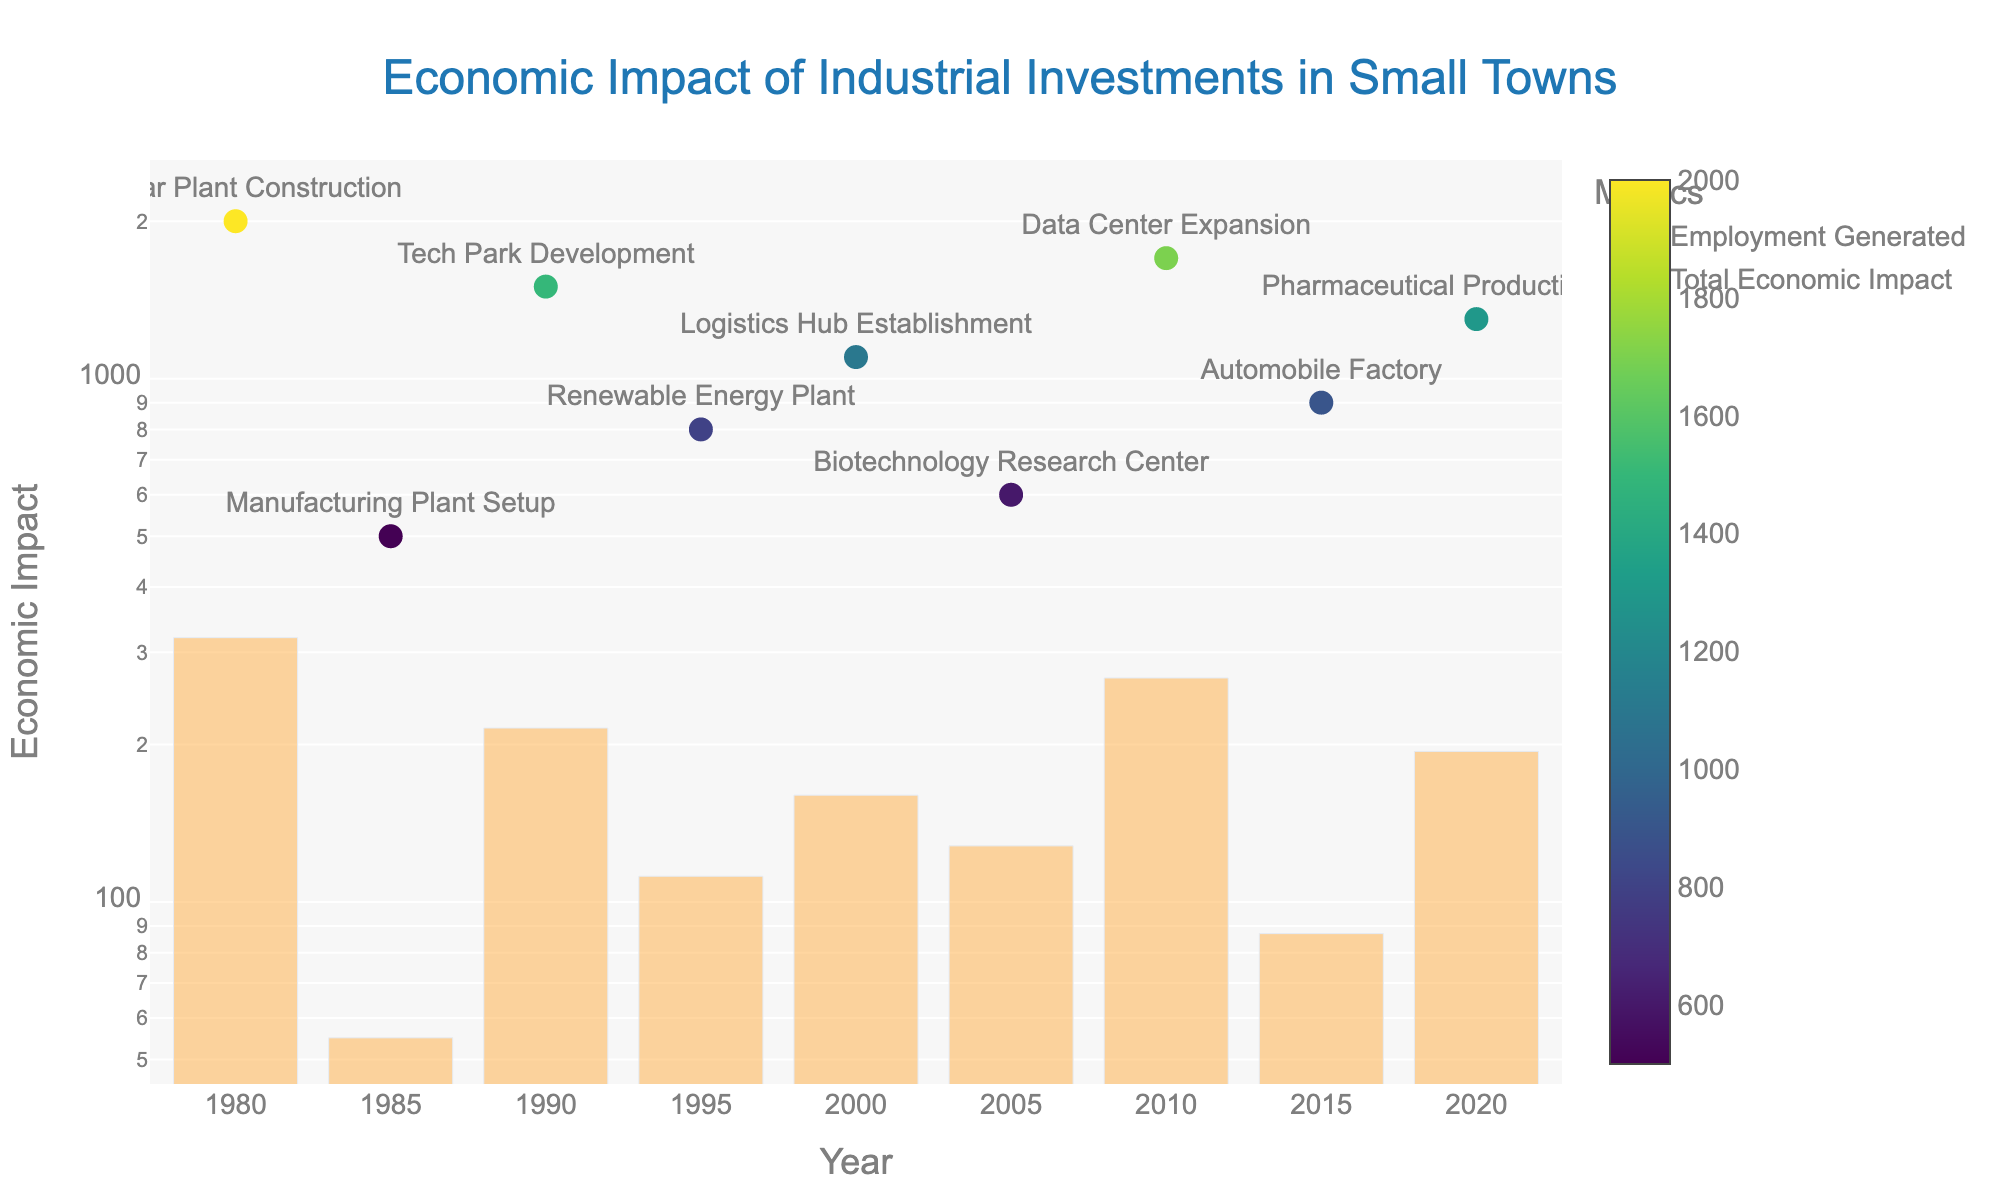What is the title of the figure? The title of the figure is written at the top center of the plot. It conveys the primary topic that the figure represents.
Answer: Economic Impact of Industrial Investments in Small Towns What is the y-axis representing? The y-axis on the right side of the plot encompasses two main metrics: "Employment Generated" and "Total Economic Impact" on a log scale.
Answer: Economic Impact What year shows the highest employment generated? To find the year with the highest employment generated, identify the highest point in the scatter plot and check the hover text or label for that data point which indicates the year.
Answer: 1980 Which investment type had the lowest initial investment? Refer to the bar chart and find the shortest bar, then check the corresponding year for that bar. Refer to the hover text or associated labels to identify the investment type.
Answer: Manufacturing Plant Setup How does the Employment Generated in 2010 compare to 2015? Refer to the scatter points of 2010 and 2015. Note their vertical positions to see which is higher and compare the numeric value.
Answer: 2010 had higher employment What is the total economic impact of the year with Tech Park Development? Find the bar corresponding to the year 1990 (Tech Park Development) and read the value from the y-axis to get the total economic impact.
Answer: 215 ($ million) Which investment type generated the most annual revenue? Annual revenue is part of the hover text on the scatter plot and can be checked for each point. Identify which investment type has the highest yearly revenue.
Answer: Nuclear Plant Construction What relationship do you observe between the initial investment and total economic impact? By observing the height of the bars and the size of the scatter points, one can identify whether higher initial investments lead to higher total economic impacts.
Answer: Generally, higher initial investments correspond to larger total economic impact What's the difference in total economic impact between 2000 and 2020? Find the respective heights of the bars for 2000 and 2020, subtract the smaller value from the larger one.
Answer: 24 ($ million) In which year did the smallest employment generation occur? Identify the scatter point closest to the bottom of the plot and read the year next to it.
Answer: 2005 